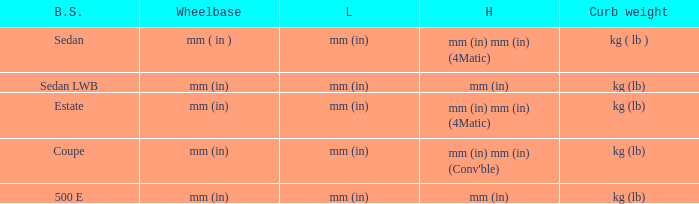What's the curb weight of the model with a wheelbase of mm (in) and height of mm (in) mm (in) (4Matic)? Kg ( lb ), kg (lb). 